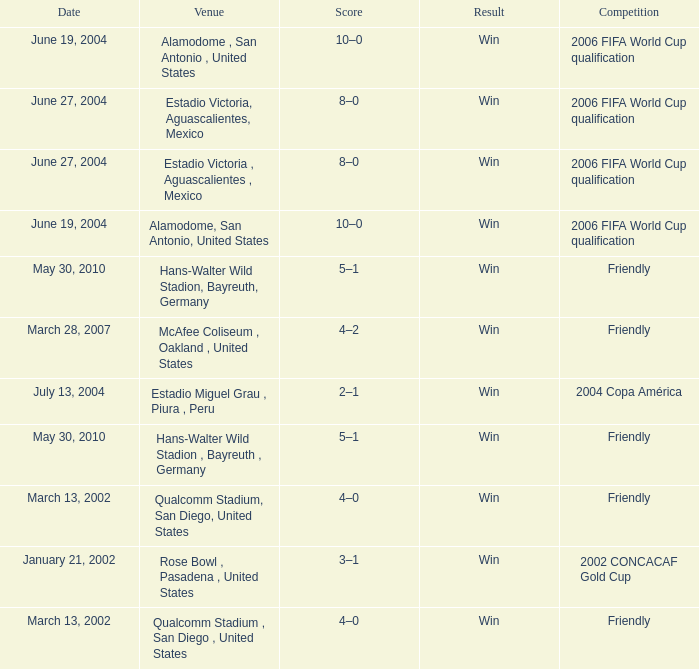What competition has June 19, 2004 as the date? 2006 FIFA World Cup qualification, 2006 FIFA World Cup qualification. 